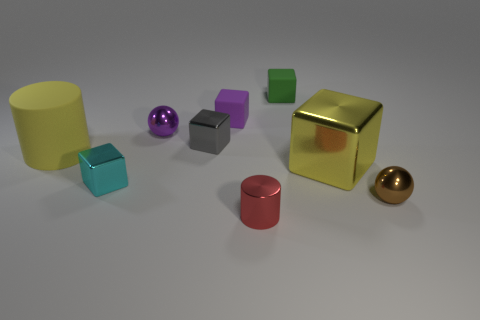How many other things are the same color as the big cube?
Provide a short and direct response. 1. There is a block that is in front of the purple cube and on the right side of the purple cube; what color is it?
Your answer should be compact. Yellow. Is the number of big blocks less than the number of rubber blocks?
Your answer should be very brief. Yes. There is a large matte cylinder; is it the same color as the big thing on the right side of the small cylinder?
Offer a terse response. Yes. Are there an equal number of large yellow metal cubes in front of the small brown shiny thing and metallic blocks to the right of the small green rubber cube?
Your response must be concise. No. What number of green rubber things are the same shape as the gray thing?
Your answer should be very brief. 1. Are there any red spheres?
Keep it short and to the point. No. Does the small brown ball have the same material as the purple object that is right of the purple sphere?
Offer a very short reply. No. What is the material of the yellow cube that is the same size as the yellow cylinder?
Give a very brief answer. Metal. Are there any big cylinders made of the same material as the big yellow block?
Your response must be concise. No. 